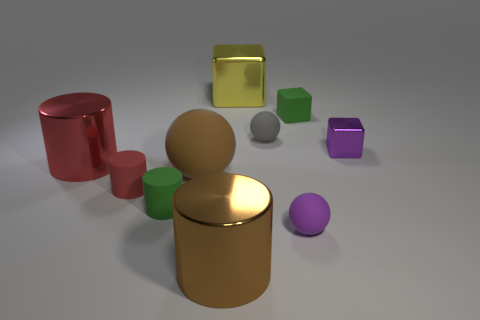Subtract all shiny blocks. How many blocks are left? 1 Subtract all cyan cubes. How many red cylinders are left? 2 Subtract all green cylinders. How many cylinders are left? 3 Subtract all cubes. How many objects are left? 7 Subtract all red blocks. Subtract all green rubber objects. How many objects are left? 8 Add 8 big yellow metal cubes. How many big yellow metal cubes are left? 9 Add 2 purple objects. How many purple objects exist? 4 Subtract 1 red cylinders. How many objects are left? 9 Subtract all blue balls. Subtract all gray cylinders. How many balls are left? 3 